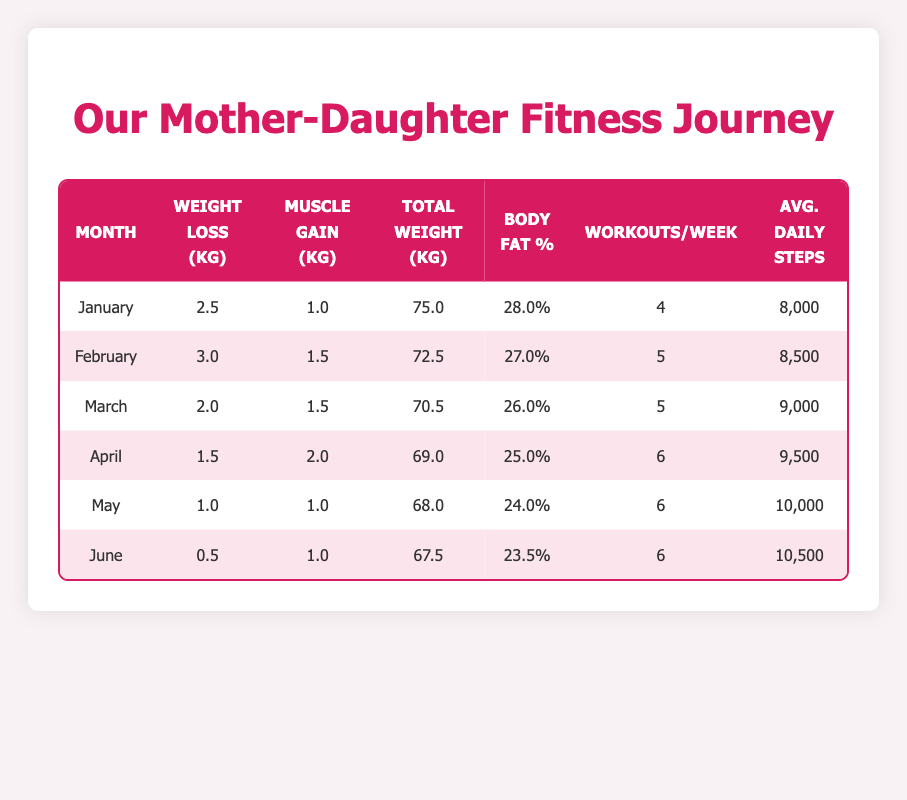What was the total weight loss in March? The table shows that in March, the weight loss was recorded as 2.0 kg.
Answer: 2.0 kg In which month was the highest muscle gain achieved? By looking at the muscle gain values, April has the highest muscle gain of 2.0 kg.
Answer: April What is the average weight loss from January to June? The total weight loss from January to June is 2.5 + 3.0 + 2.0 + 1.5 + 1.0 + 0.5 = 10.5 kg. There are 6 months, so the average is 10.5 / 6 = 1.75 kg.
Answer: 1.75 kg Was there a decrease in body fat percentage from January to February? In January, the body fat percentage was 28.0%, and in February, it was 27.0%, indicating a decrease.
Answer: Yes What is the total number of workouts per week from April to June? The total workouts for these months are 6 (April) + 6 (May) + 6 (June) = 18.
Answer: 18 workouts What was the change in average daily steps from January to June? The average daily steps increased from 8,000 in January to 10,500 in June. The change is 10,500 - 8,000 = 2,500 steps.
Answer: 2,500 steps Is it true that muscle gain was greater than weight loss in April? In April, muscle gain was 2.0 kg and weight loss was 1.5 kg, so muscle gain is greater than weight loss.
Answer: Yes What was the percentage decrease in body fat from January to June? The body fat percentage decreased from 28.0% (January) to 23.5% (June), which is a decrease of 28.0 - 23.5 = 4.5%.
Answer: 4.5% 